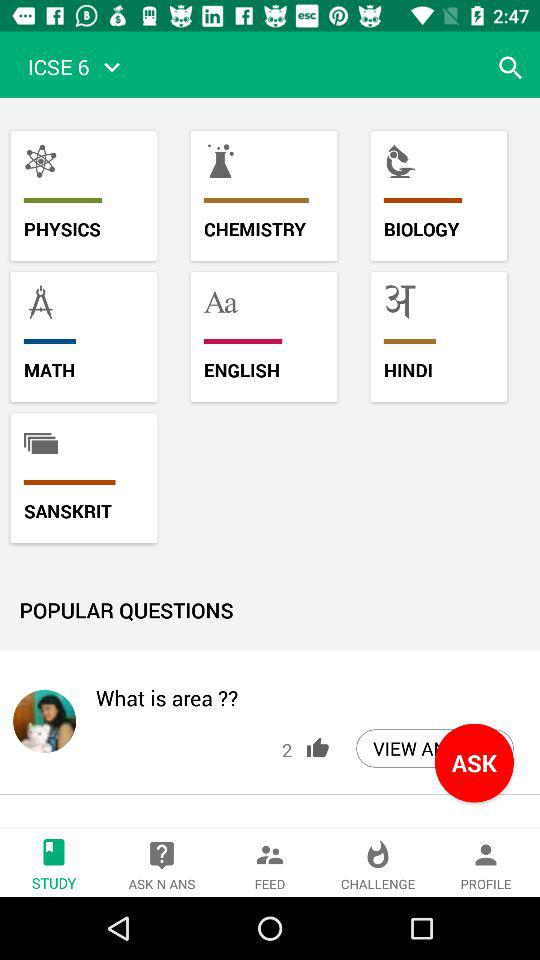Which tab is selected? The selected tab is "STUDY". 